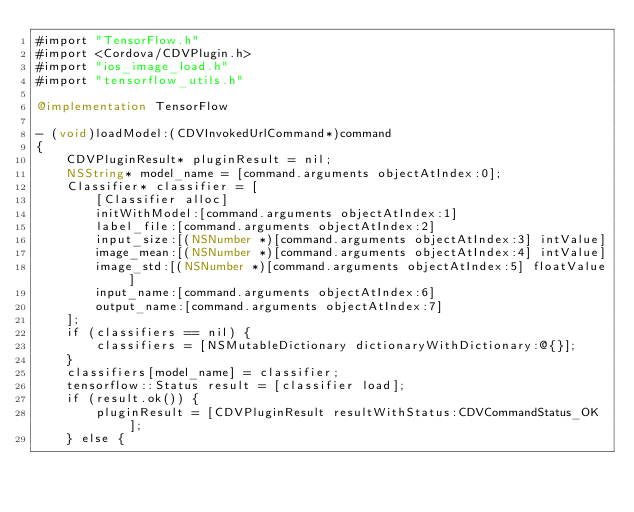Convert code to text. <code><loc_0><loc_0><loc_500><loc_500><_ObjectiveC_>#import "TensorFlow.h"
#import <Cordova/CDVPlugin.h>
#import "ios_image_load.h"
#import "tensorflow_utils.h"

@implementation TensorFlow

- (void)loadModel:(CDVInvokedUrlCommand*)command
{
    CDVPluginResult* pluginResult = nil;
    NSString* model_name = [command.arguments objectAtIndex:0];
    Classifier* classifier = [
        [Classifier alloc]
        initWithModel:[command.arguments objectAtIndex:1]
        label_file:[command.arguments objectAtIndex:2]
        input_size:[(NSNumber *)[command.arguments objectAtIndex:3] intValue]
        image_mean:[(NSNumber *)[command.arguments objectAtIndex:4] intValue]
        image_std:[(NSNumber *)[command.arguments objectAtIndex:5] floatValue]
        input_name:[command.arguments objectAtIndex:6]
        output_name:[command.arguments objectAtIndex:7]
    ];
    if (classifiers == nil) {
        classifiers = [NSMutableDictionary dictionaryWithDictionary:@{}];
    }
    classifiers[model_name] = classifier;
    tensorflow::Status result = [classifier load];
    if (result.ok()) {
        pluginResult = [CDVPluginResult resultWithStatus:CDVCommandStatus_OK];
    } else {</code> 